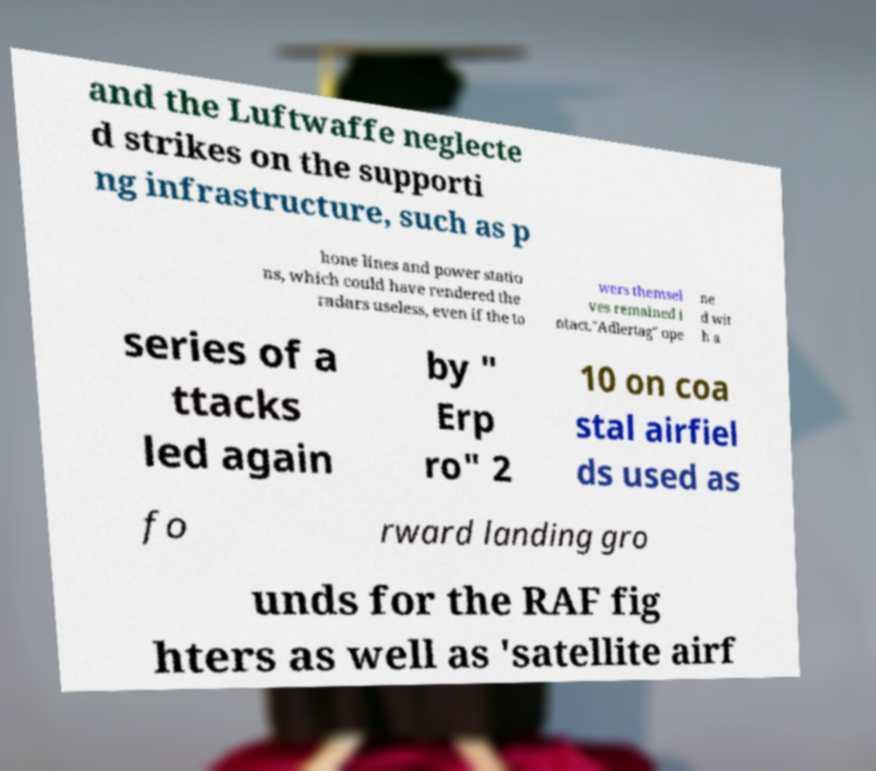Can you accurately transcribe the text from the provided image for me? and the Luftwaffe neglecte d strikes on the supporti ng infrastructure, such as p hone lines and power statio ns, which could have rendered the radars useless, even if the to wers themsel ves remained i ntact."Adlertag" ope ne d wit h a series of a ttacks led again by " Erp ro" 2 10 on coa stal airfiel ds used as fo rward landing gro unds for the RAF fig hters as well as 'satellite airf 